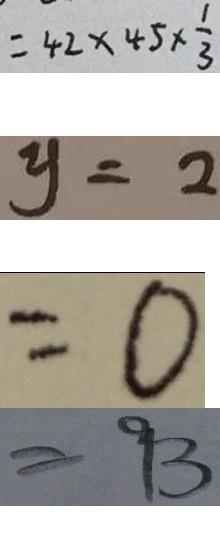<formula> <loc_0><loc_0><loc_500><loc_500>= 4 2 \times 4 5 \times \frac { 1 } { 3 } 
 y = 2 
 = 0 
 = 9 3</formula> 